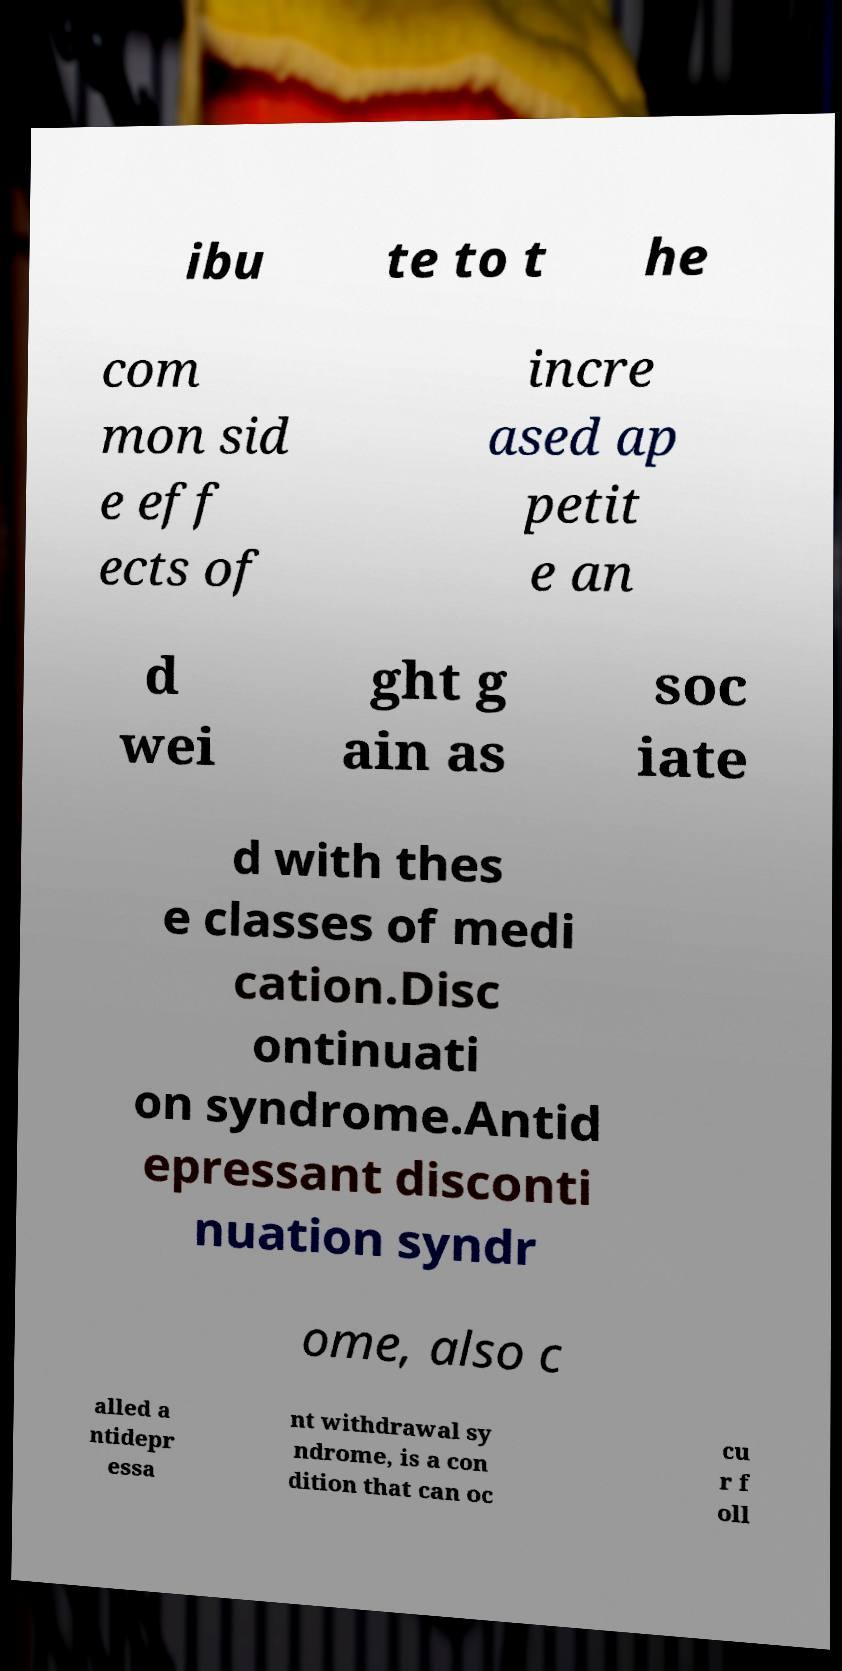I need the written content from this picture converted into text. Can you do that? ibu te to t he com mon sid e eff ects of incre ased ap petit e an d wei ght g ain as soc iate d with thes e classes of medi cation.Disc ontinuati on syndrome.Antid epressant disconti nuation syndr ome, also c alled a ntidepr essa nt withdrawal sy ndrome, is a con dition that can oc cu r f oll 